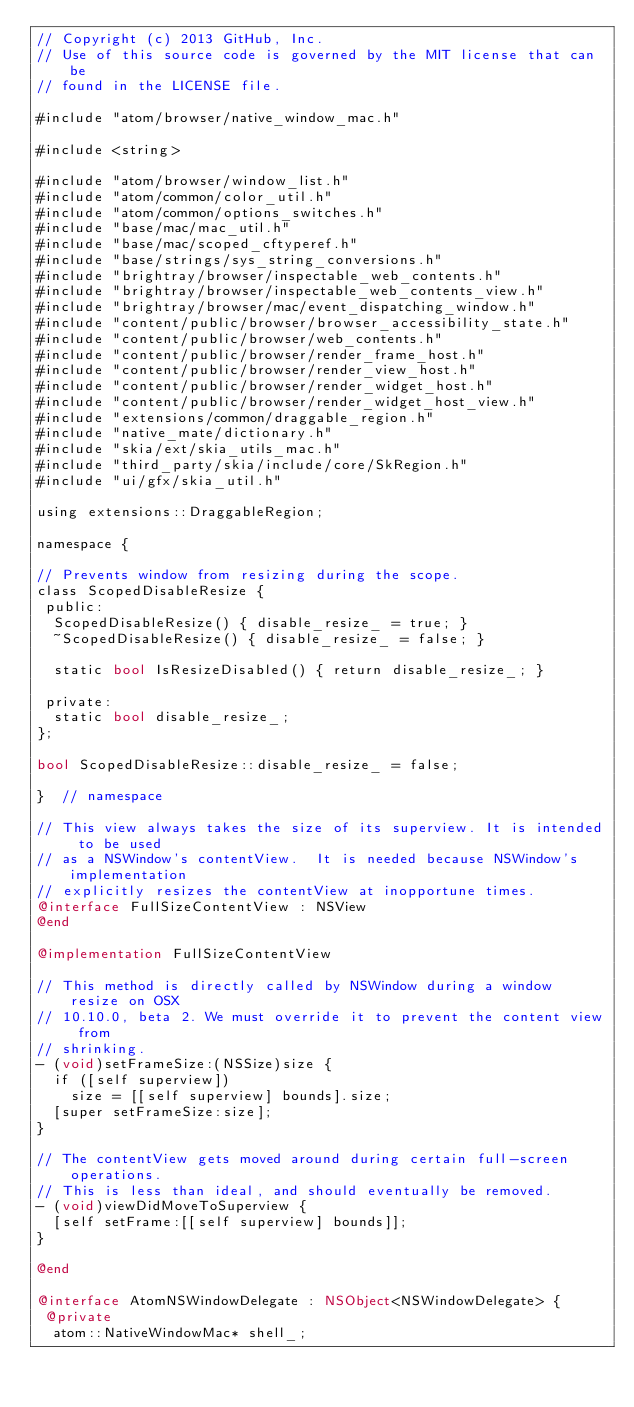<code> <loc_0><loc_0><loc_500><loc_500><_ObjectiveC_>// Copyright (c) 2013 GitHub, Inc.
// Use of this source code is governed by the MIT license that can be
// found in the LICENSE file.

#include "atom/browser/native_window_mac.h"

#include <string>

#include "atom/browser/window_list.h"
#include "atom/common/color_util.h"
#include "atom/common/options_switches.h"
#include "base/mac/mac_util.h"
#include "base/mac/scoped_cftyperef.h"
#include "base/strings/sys_string_conversions.h"
#include "brightray/browser/inspectable_web_contents.h"
#include "brightray/browser/inspectable_web_contents_view.h"
#include "brightray/browser/mac/event_dispatching_window.h"
#include "content/public/browser/browser_accessibility_state.h"
#include "content/public/browser/web_contents.h"
#include "content/public/browser/render_frame_host.h"
#include "content/public/browser/render_view_host.h"
#include "content/public/browser/render_widget_host.h"
#include "content/public/browser/render_widget_host_view.h"
#include "extensions/common/draggable_region.h"
#include "native_mate/dictionary.h"
#include "skia/ext/skia_utils_mac.h"
#include "third_party/skia/include/core/SkRegion.h"
#include "ui/gfx/skia_util.h"

using extensions::DraggableRegion;

namespace {

// Prevents window from resizing during the scope.
class ScopedDisableResize {
 public:
  ScopedDisableResize() { disable_resize_ = true; }
  ~ScopedDisableResize() { disable_resize_ = false; }

  static bool IsResizeDisabled() { return disable_resize_; }

 private:
  static bool disable_resize_;
};

bool ScopedDisableResize::disable_resize_ = false;

}  // namespace

// This view always takes the size of its superview. It is intended to be used
// as a NSWindow's contentView.  It is needed because NSWindow's implementation
// explicitly resizes the contentView at inopportune times.
@interface FullSizeContentView : NSView
@end

@implementation FullSizeContentView

// This method is directly called by NSWindow during a window resize on OSX
// 10.10.0, beta 2. We must override it to prevent the content view from
// shrinking.
- (void)setFrameSize:(NSSize)size {
  if ([self superview])
    size = [[self superview] bounds].size;
  [super setFrameSize:size];
}

// The contentView gets moved around during certain full-screen operations.
// This is less than ideal, and should eventually be removed.
- (void)viewDidMoveToSuperview {
  [self setFrame:[[self superview] bounds]];
}

@end

@interface AtomNSWindowDelegate : NSObject<NSWindowDelegate> {
 @private
  atom::NativeWindowMac* shell_;</code> 